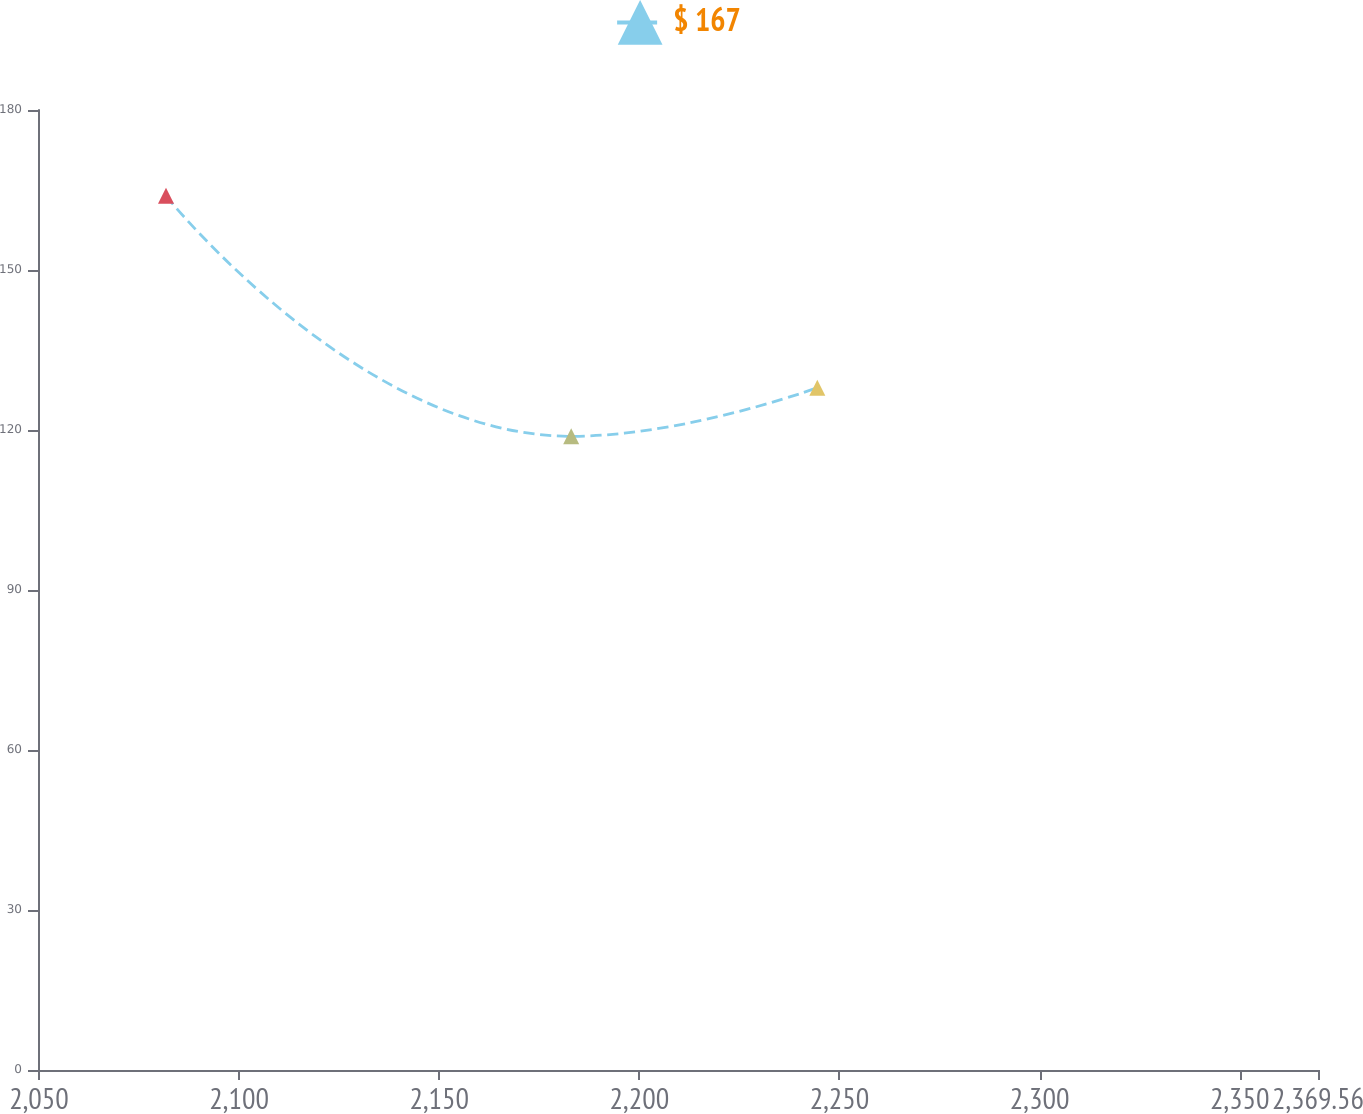Convert chart. <chart><loc_0><loc_0><loc_500><loc_500><line_chart><ecel><fcel>$ 167<nl><fcel>2081.74<fcel>163.9<nl><fcel>2182.98<fcel>118.82<nl><fcel>2244.47<fcel>127.92<nl><fcel>2401.54<fcel>96.05<nl></chart> 